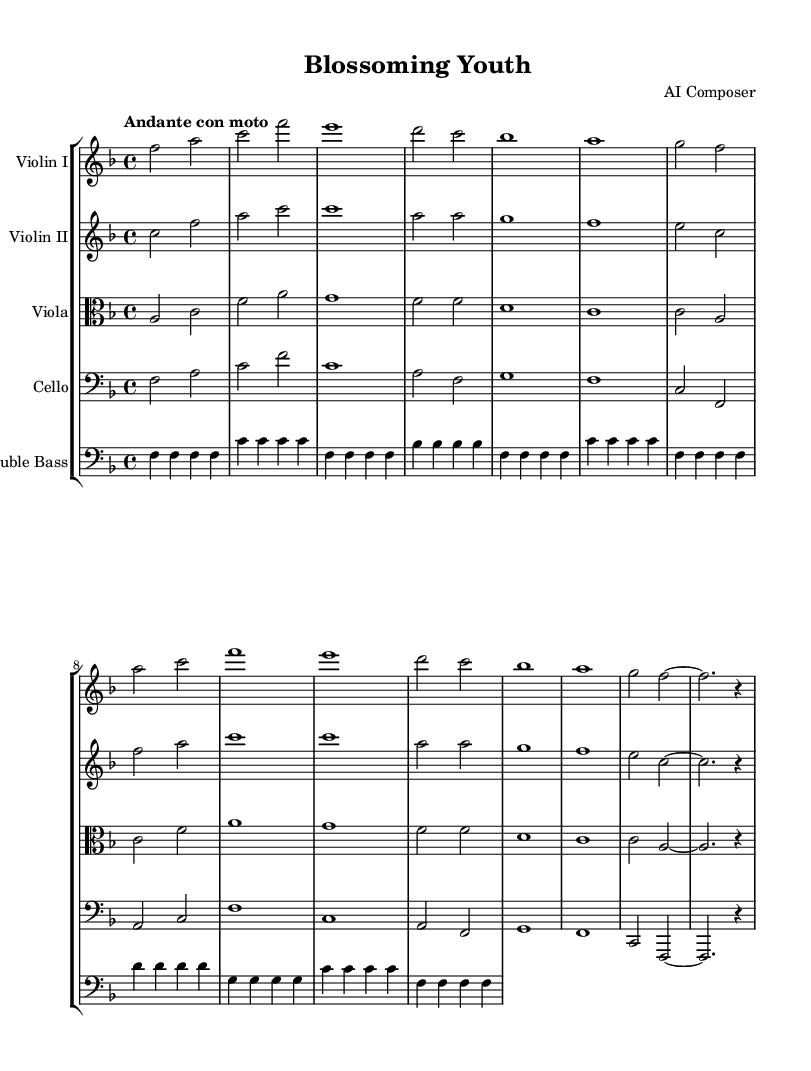What is the key signature of this music? The key signature is F major, which has one flat (B flat). You can determine this by looking at the key signature placed at the beginning of the staff.
Answer: F major What is the time signature of this music? The time signature is 4/4, indicated at the beginning of the score. This means there are four beats in each measure and a quarter note receives one beat.
Answer: 4/4 What is the tempo marking of this piece? The tempo marking is "Andante con moto," which suggests a moderately slow tempo with a bit of movement. You can find it at the beginning of the score.
Answer: Andante con moto How many measures does the piece have? The piece consists of 16 measures. By counting the vertical lines (bar lines) that separate the musical phrases in the score, you can find the number of measures.
Answer: 16 Which instruments are included in this orchestral piece? The piece includes violin I, violin II, viola, cello, and double bass. This information is found in the staff group header along with the individual instrument staves.
Answer: Violin I, Violin II, Viola, Cello, Double Bass What is the highest note played by the Violin I in this score? The highest note played by Violin I is C. You can identify the notes by observing the staff lines and spaces where the notes are notated.
Answer: C What is the overall mood suggested by this Romantic orchestral piece? The overall mood is romantic and introspective, as suggested by the melodic lines and moderate tempo. This mood is characteristic of pieces inspired by coming-of-age themes.
Answer: Romantic and introspective 